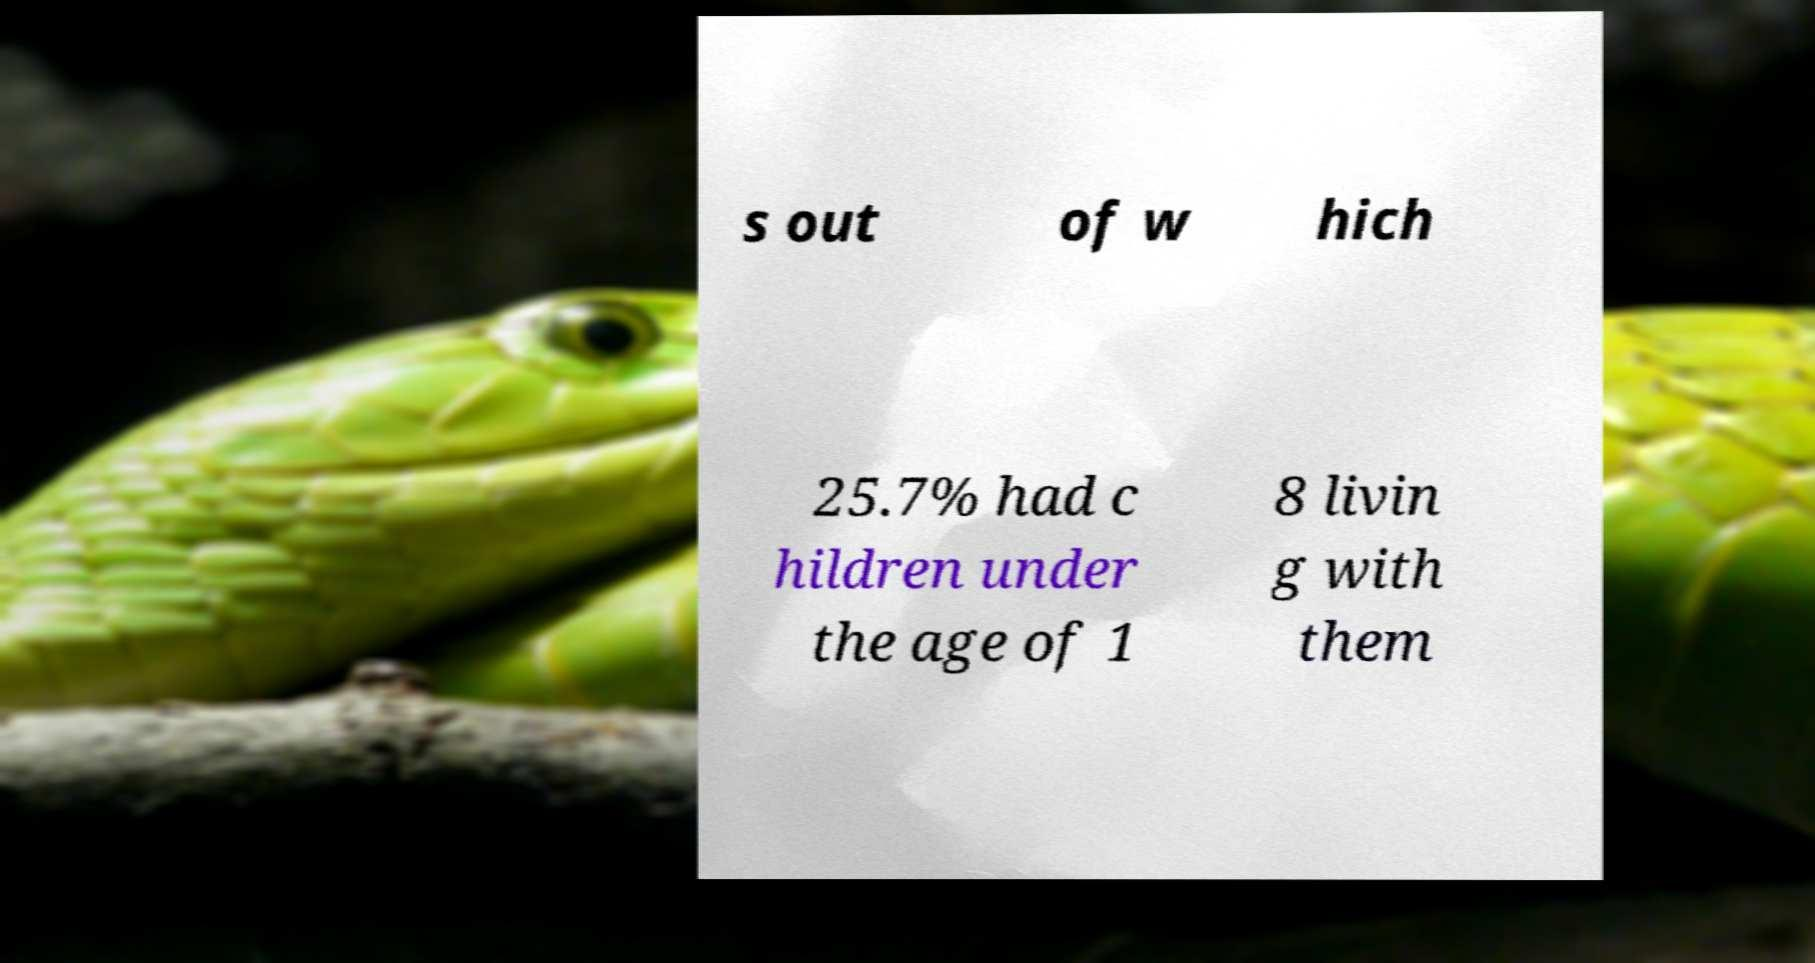Could you extract and type out the text from this image? s out of w hich 25.7% had c hildren under the age of 1 8 livin g with them 